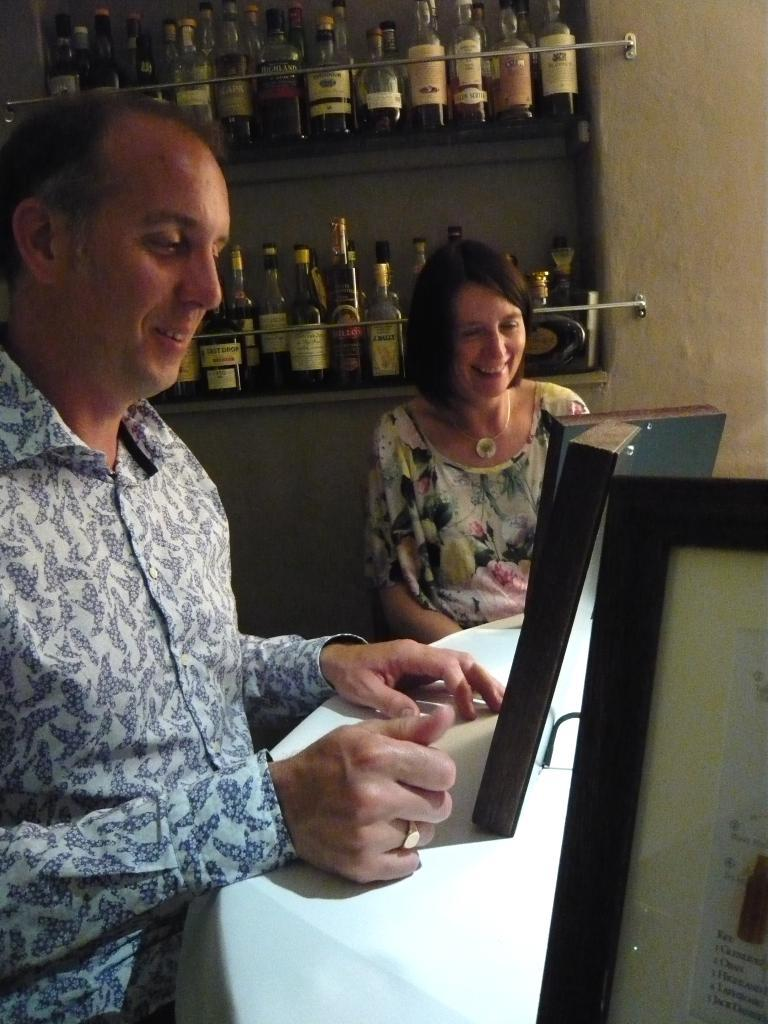Who is present in the image? There is a man and a woman in the image. What are the man and woman doing in the image? The man and woman are at a table and looking at frames. What else can be seen in the image? There are wine bottles visible in the image. What type of bed can be seen in the image? There is no bed present in the image. Can you tell me how many worms are crawling on the table in the image? There are no worms present in the image; it features a man and a woman looking at frames and wine bottles on a table. 